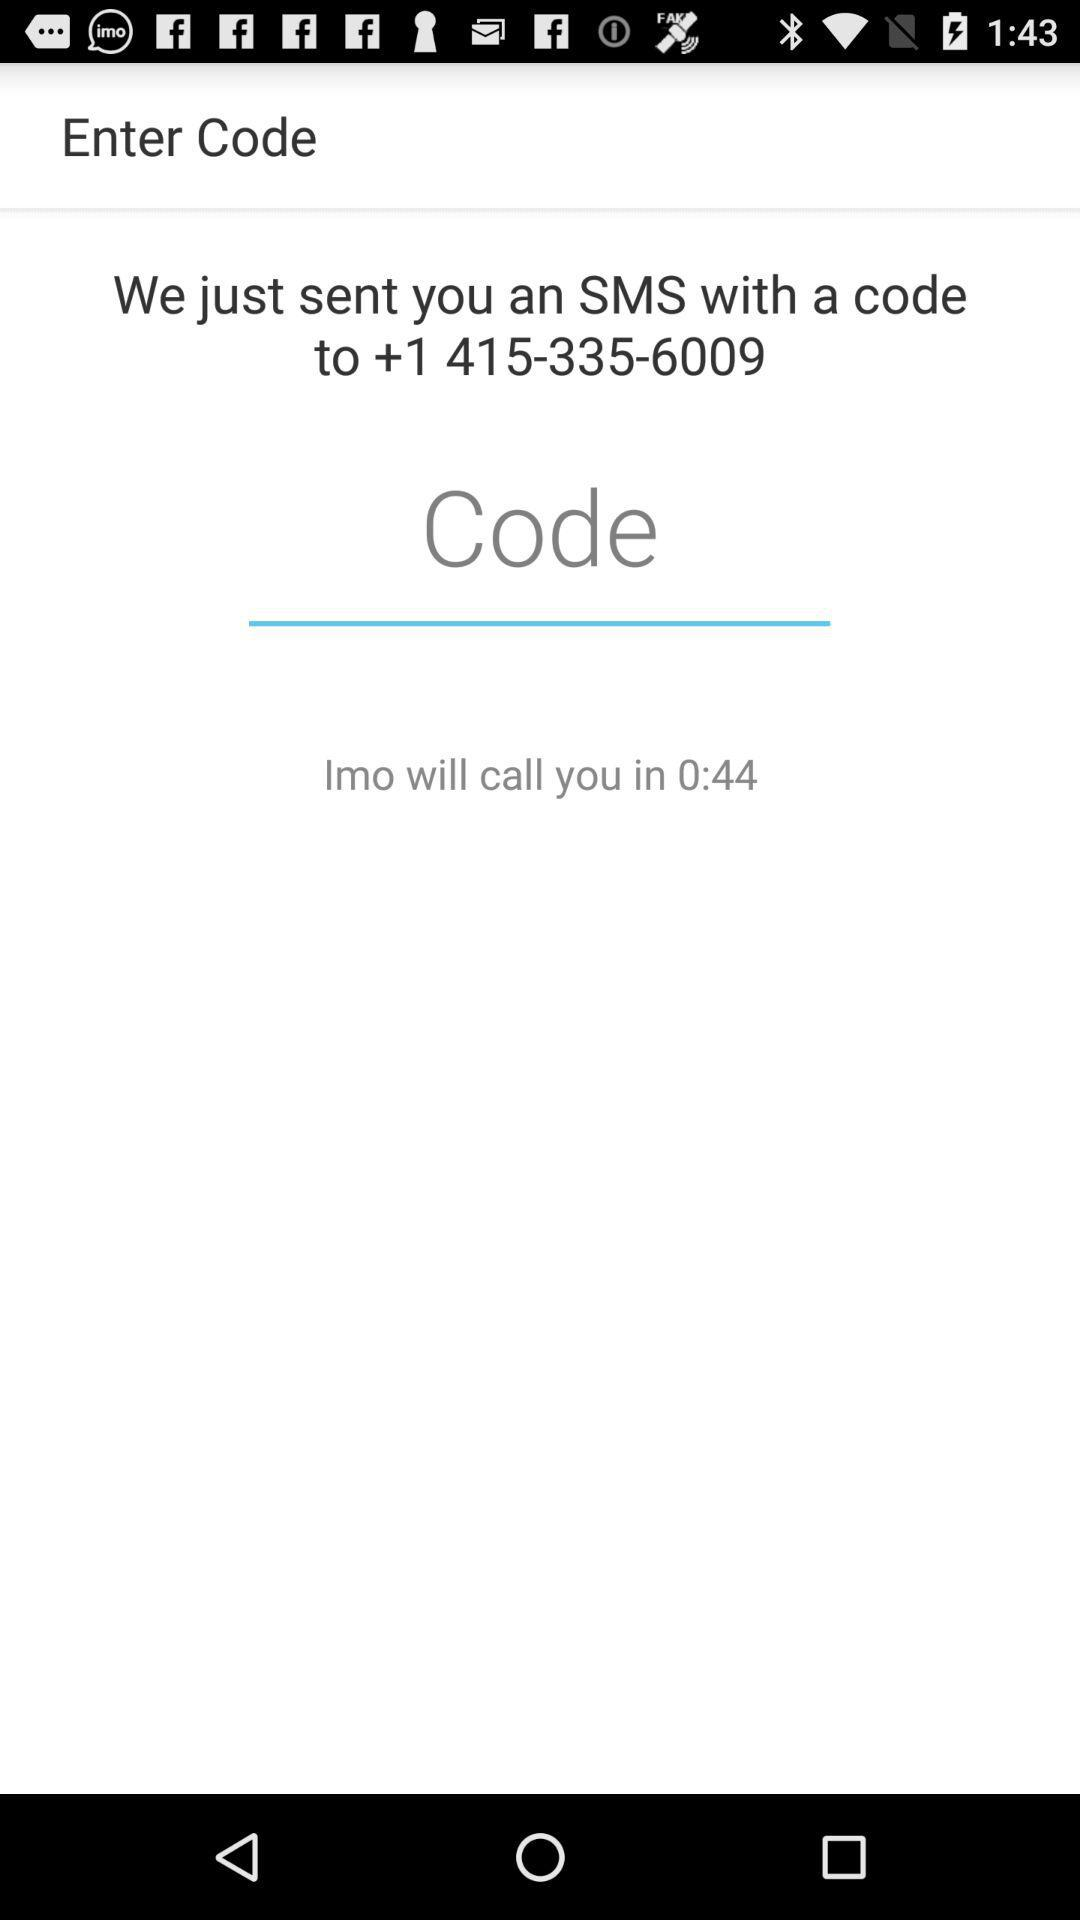How much time do we have to verify the number? The time is 0:44. 